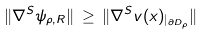<formula> <loc_0><loc_0><loc_500><loc_500>\| \nabla ^ { S } \psi _ { \rho , R } \| \, \geq \, \| \nabla ^ { S } v ( x ) _ { | _ { \partial D _ { \rho } } } \|</formula> 